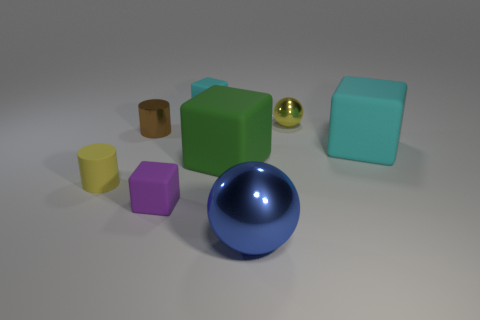There is a small object that is the same color as the small rubber cylinder; what is it made of?
Ensure brevity in your answer.  Metal. Do the small matte cylinder and the tiny ball have the same color?
Give a very brief answer. Yes. Is the color of the tiny matte cylinder the same as the small thing that is on the right side of the blue metal object?
Provide a short and direct response. Yes. How many other things are there of the same material as the large green cube?
Keep it short and to the point. 4. There is a yellow thing that is made of the same material as the small brown object; what is its shape?
Offer a terse response. Sphere. Are there any other things that are the same color as the rubber cylinder?
Your answer should be very brief. Yes. Is the number of blue metallic spheres behind the blue metallic thing the same as the number of small yellow shiny objects that are to the left of the big cyan rubber object?
Offer a terse response. No. What is the shape of the small matte object that is the same color as the small sphere?
Your answer should be very brief. Cylinder. What color is the ball that is the same size as the yellow cylinder?
Your answer should be very brief. Yellow. What is the material of the large cyan thing?
Make the answer very short. Rubber. 